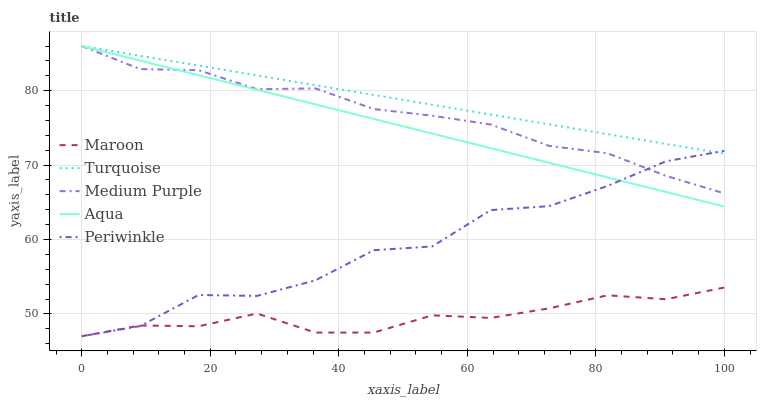Does Maroon have the minimum area under the curve?
Answer yes or no. Yes. Does Turquoise have the maximum area under the curve?
Answer yes or no. Yes. Does Periwinkle have the minimum area under the curve?
Answer yes or no. No. Does Periwinkle have the maximum area under the curve?
Answer yes or no. No. Is Turquoise the smoothest?
Answer yes or no. Yes. Is Periwinkle the roughest?
Answer yes or no. Yes. Is Periwinkle the smoothest?
Answer yes or no. No. Is Turquoise the roughest?
Answer yes or no. No. Does Periwinkle have the lowest value?
Answer yes or no. Yes. Does Turquoise have the lowest value?
Answer yes or no. No. Does Aqua have the highest value?
Answer yes or no. Yes. Does Periwinkle have the highest value?
Answer yes or no. No. Is Maroon less than Aqua?
Answer yes or no. Yes. Is Turquoise greater than Maroon?
Answer yes or no. Yes. Does Periwinkle intersect Aqua?
Answer yes or no. Yes. Is Periwinkle less than Aqua?
Answer yes or no. No. Is Periwinkle greater than Aqua?
Answer yes or no. No. Does Maroon intersect Aqua?
Answer yes or no. No. 